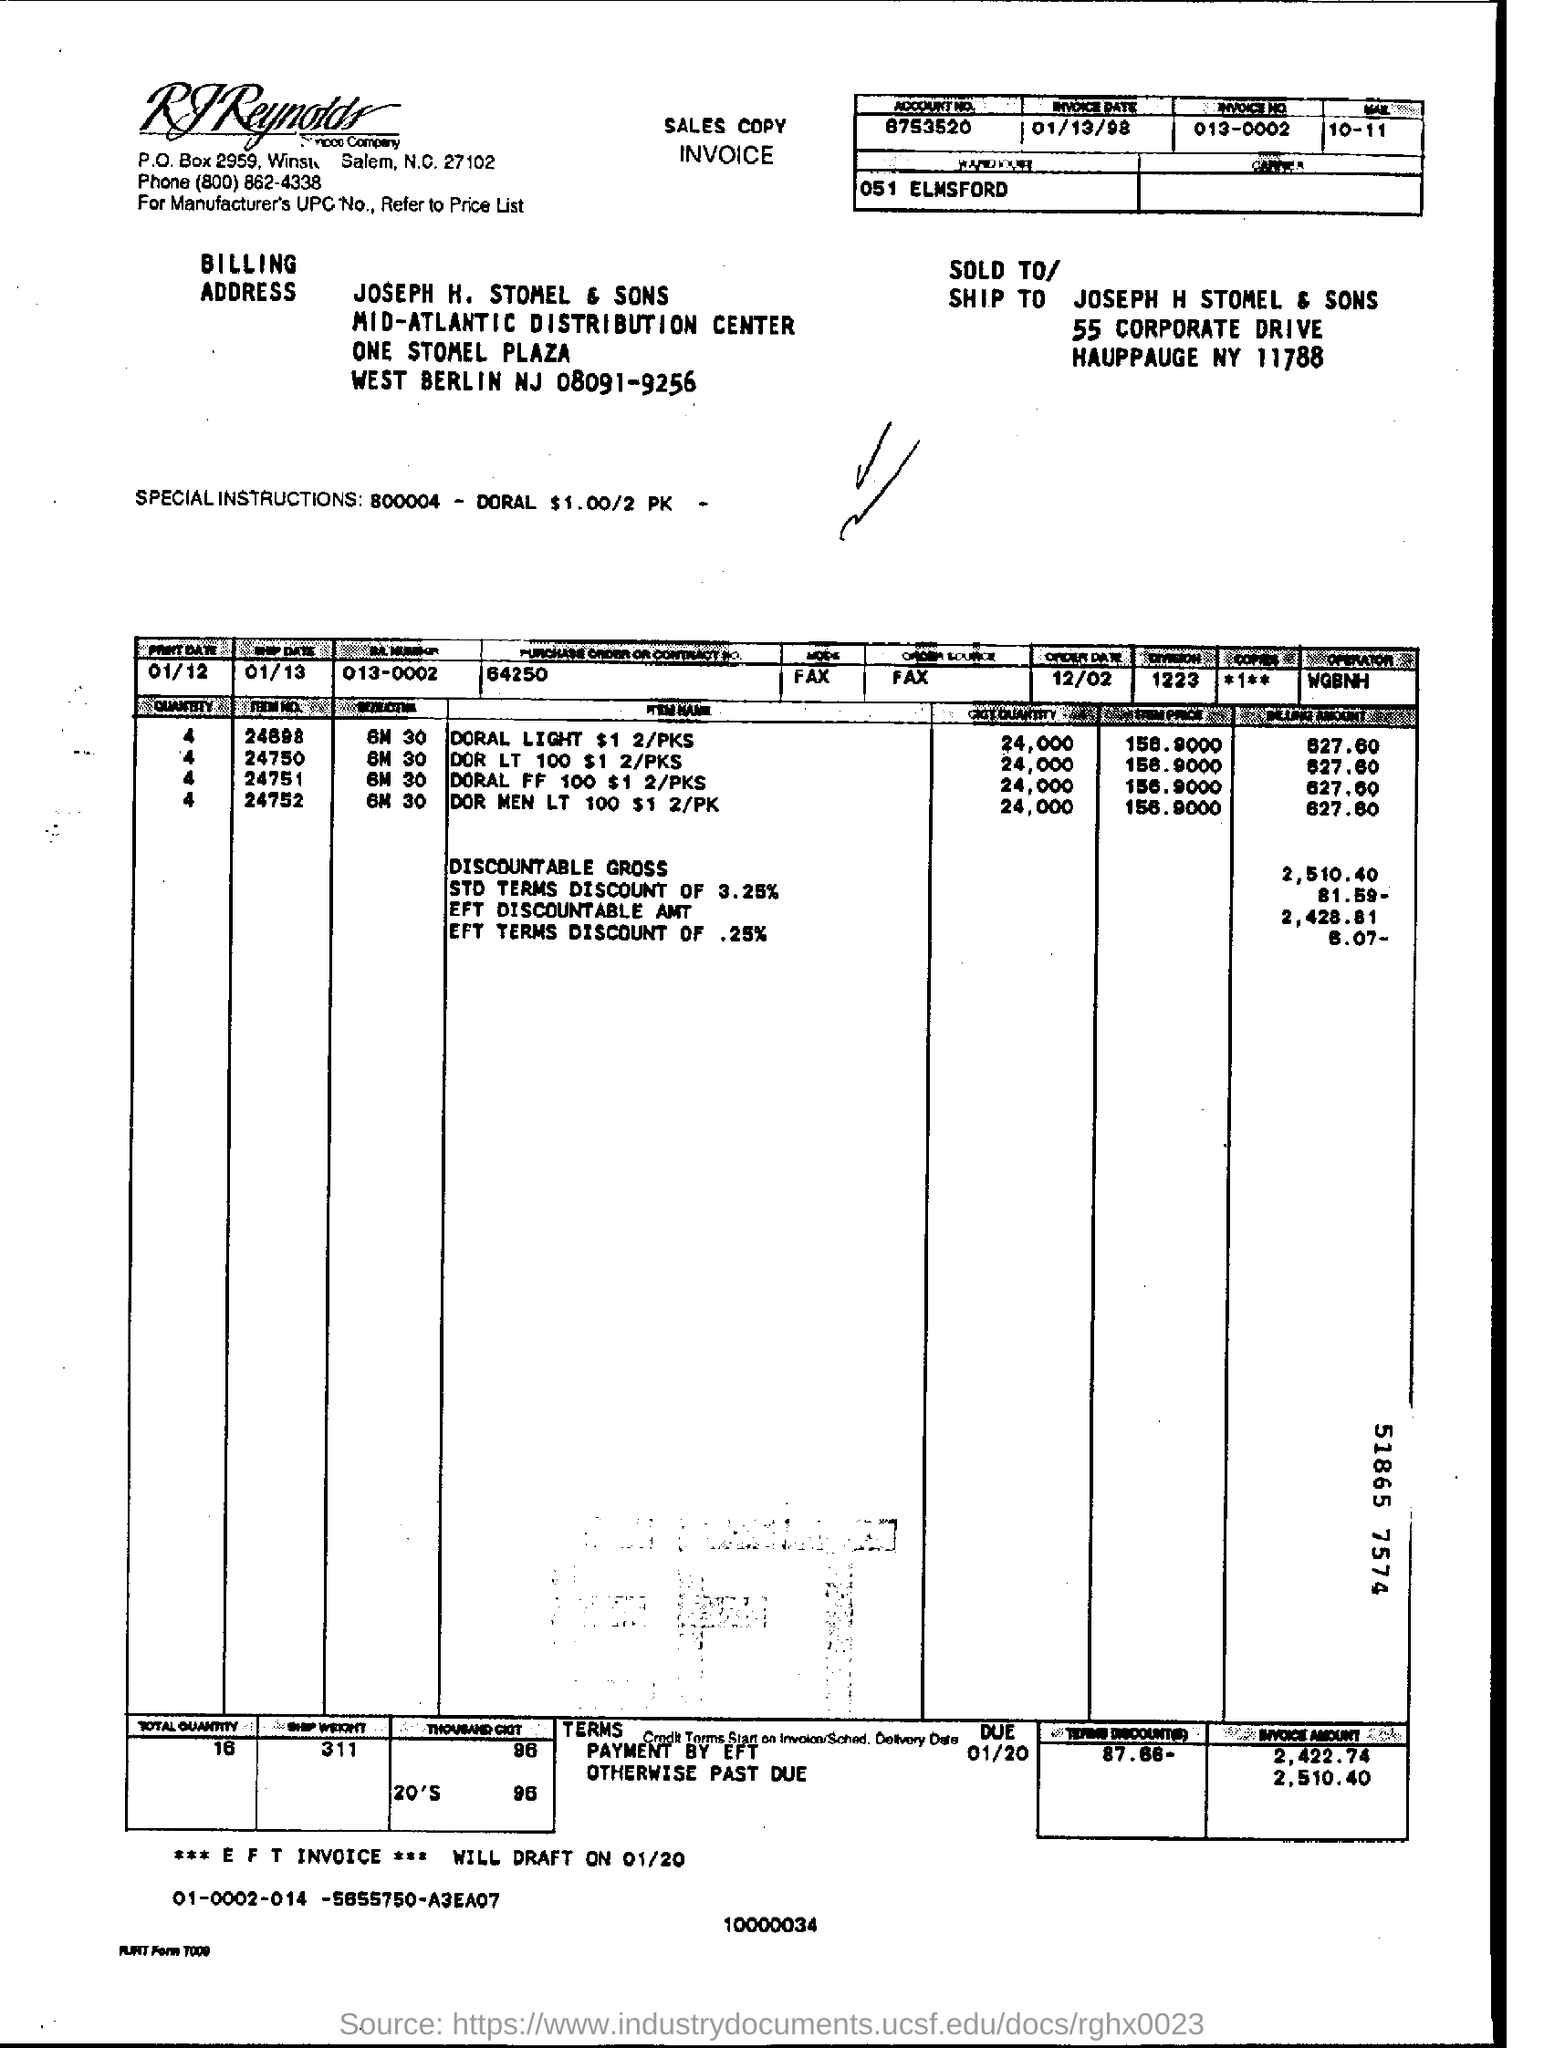When will  ***E F T INVOICE *** WILL DRAFT ON ?
Give a very brief answer. 01/20. What is the order date ?
Ensure brevity in your answer.  12/02. What is the invoice date ?
Give a very brief answer. 01/13/98. 